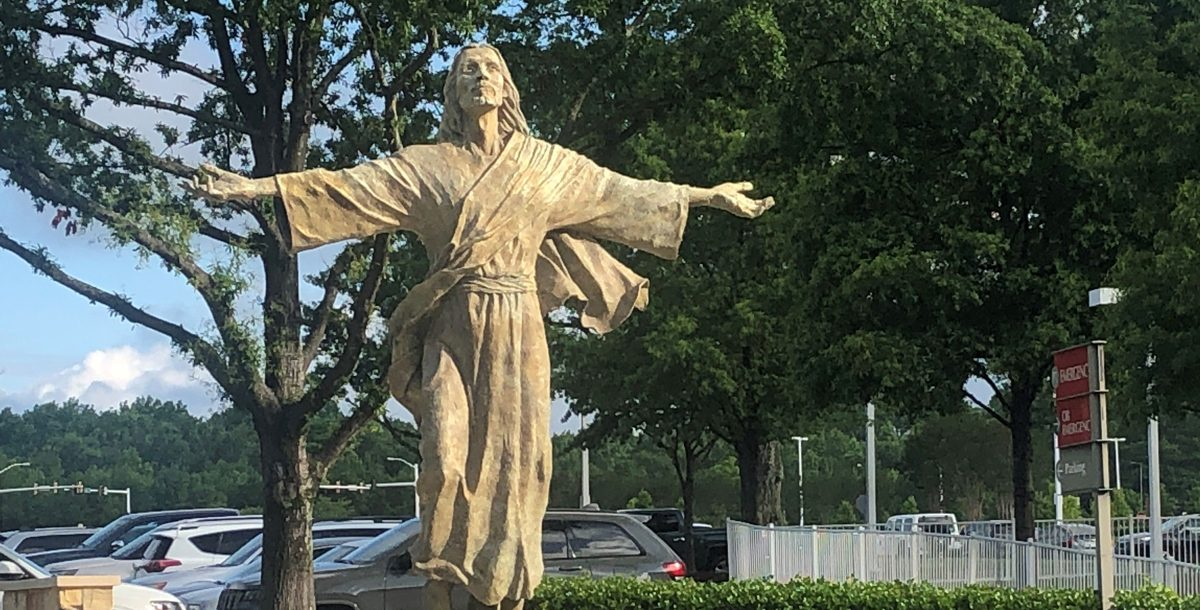Considering the placement and design of the statue, what might be the significance or purpose of this statue in its location, and how does it interact with its surroundings to convey its intended message or impression to onlookers? The statue, depicting a figure with arms spread wide in a benevolent gesture, dressed in flowing robes, suggests it represents a figure of peace or spiritual importance. Its central placement in a busy parking area not only makes it easily accessible to the public but suggests it serves as a spiritual or calming influence amidst everyday hustle. The openness of its arms, together with its upward-facing posture, could be interpreted as an offer of welcome or embrace to all, promoting inclusivity. The backdrop of urban greenery and vast skies may enhance its presence as a beacon of tranquility and hope, standing as a silent guardian or guide, offering a moment of respite and reflection to those who pass by. 